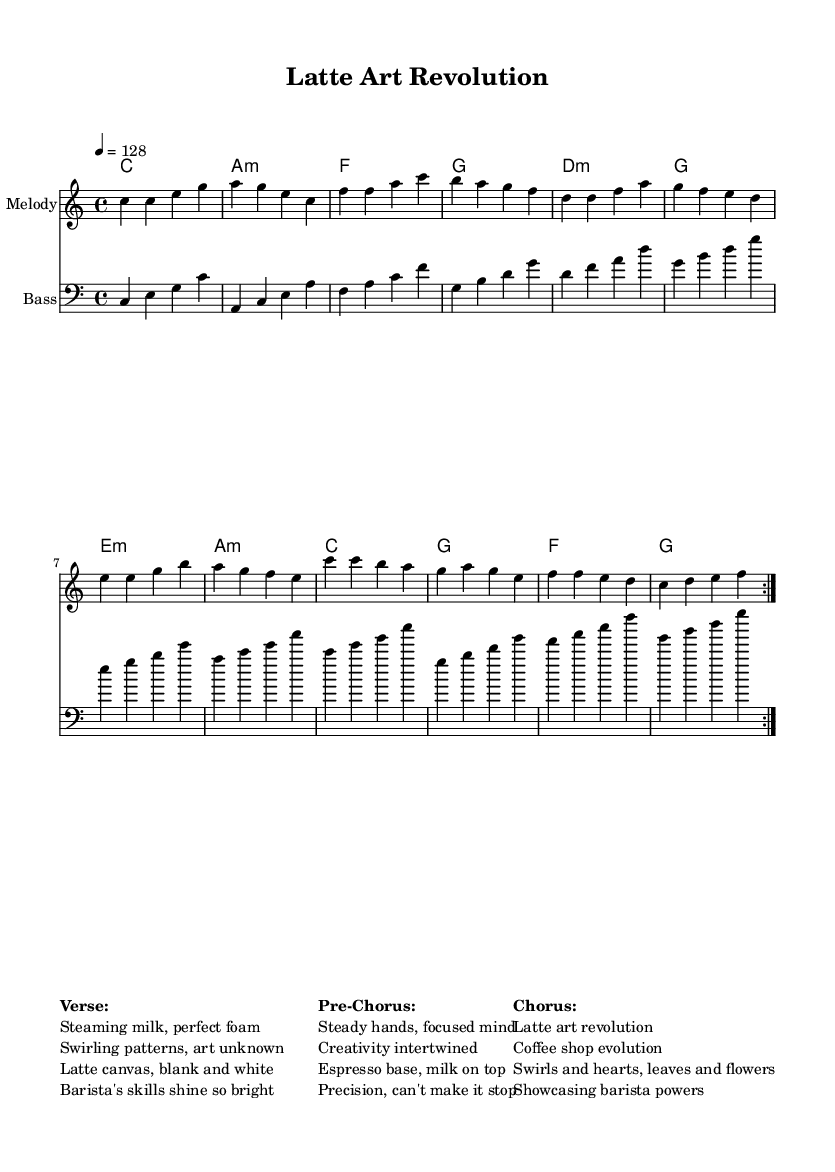What is the key signature of this music? The key signature is indicated at the beginning of the score; it is C major, which has no sharps or flats.
Answer: C major What is the time signature of this music? The time signature can be found at the beginning of the music, stated as 4/4, which indicates four beats in each measure.
Answer: 4/4 What is the tempo marking of the piece? The tempo marking is located at the beginning of the score, which states the piece is to be played at a speed of 128 beats per minute.
Answer: 128 How many measures are repeated in the melody? The repeat sign (volta) is indicated in the melody section; it specifies that the melody is to be repeated two times.
Answer: 2 What is the main theme of the chorus? The text in the chorus section describes a "Latte art revolution" and mentions elements like swirls and barista powers, highlighting the artistic aspect of coffee preparation.
Answer: Latte art revolution What genre is this piece classified as? The overall style and elements in the score, especially the energetic tempo and vibrant melody, identify it as a K-Pop track, which is known for its catchy and upbeat sound.
Answer: K-Pop What is the significance of latte art in this music? The lyrics throughout the piece emphasize the skill and creativity involved in creating latte art, portraying it as an art form and celebrating the barista's talent in crafting beautiful coffee presentations.
Answer: Skill and creativity 